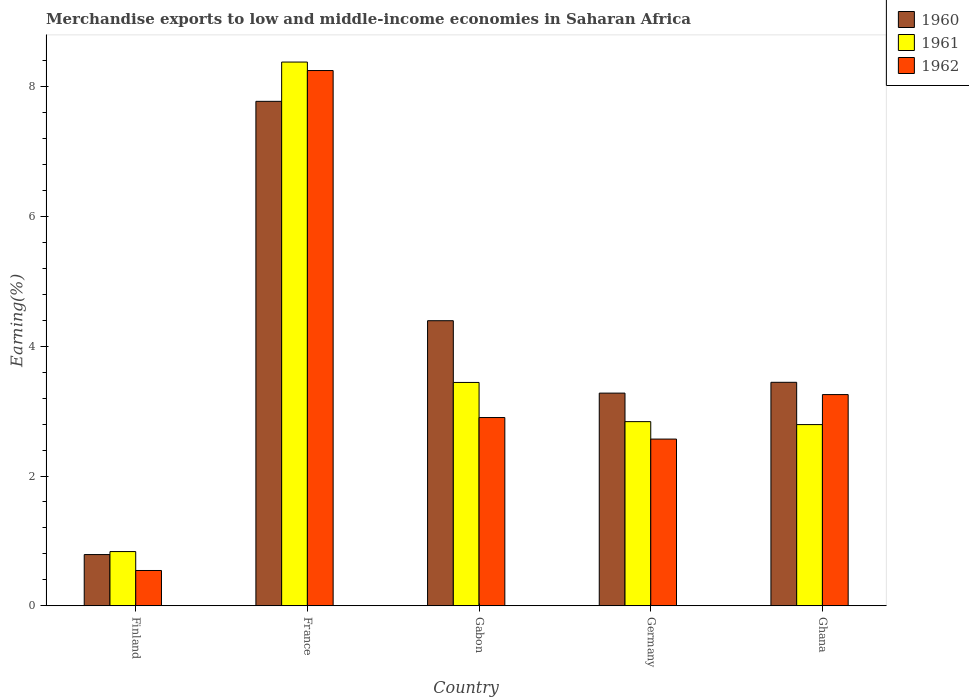How many groups of bars are there?
Your response must be concise. 5. Are the number of bars on each tick of the X-axis equal?
Make the answer very short. Yes. How many bars are there on the 4th tick from the left?
Make the answer very short. 3. What is the label of the 3rd group of bars from the left?
Make the answer very short. Gabon. In how many cases, is the number of bars for a given country not equal to the number of legend labels?
Offer a very short reply. 0. What is the percentage of amount earned from merchandise exports in 1962 in Germany?
Give a very brief answer. 2.57. Across all countries, what is the maximum percentage of amount earned from merchandise exports in 1960?
Offer a very short reply. 7.77. Across all countries, what is the minimum percentage of amount earned from merchandise exports in 1961?
Make the answer very short. 0.84. In which country was the percentage of amount earned from merchandise exports in 1961 minimum?
Give a very brief answer. Finland. What is the total percentage of amount earned from merchandise exports in 1962 in the graph?
Your answer should be compact. 17.52. What is the difference between the percentage of amount earned from merchandise exports in 1961 in France and that in Ghana?
Your answer should be very brief. 5.59. What is the difference between the percentage of amount earned from merchandise exports in 1961 in Gabon and the percentage of amount earned from merchandise exports in 1960 in Germany?
Offer a terse response. 0.16. What is the average percentage of amount earned from merchandise exports in 1962 per country?
Your answer should be very brief. 3.5. What is the difference between the percentage of amount earned from merchandise exports of/in 1960 and percentage of amount earned from merchandise exports of/in 1961 in Finland?
Offer a terse response. -0.05. In how many countries, is the percentage of amount earned from merchandise exports in 1961 greater than 4.8 %?
Your answer should be compact. 1. What is the ratio of the percentage of amount earned from merchandise exports in 1961 in Finland to that in Ghana?
Provide a short and direct response. 0.3. Is the percentage of amount earned from merchandise exports in 1961 in Gabon less than that in Germany?
Your response must be concise. No. Is the difference between the percentage of amount earned from merchandise exports in 1960 in Finland and Ghana greater than the difference between the percentage of amount earned from merchandise exports in 1961 in Finland and Ghana?
Provide a short and direct response. No. What is the difference between the highest and the second highest percentage of amount earned from merchandise exports in 1960?
Your answer should be compact. -0.95. What is the difference between the highest and the lowest percentage of amount earned from merchandise exports in 1961?
Make the answer very short. 7.54. In how many countries, is the percentage of amount earned from merchandise exports in 1962 greater than the average percentage of amount earned from merchandise exports in 1962 taken over all countries?
Make the answer very short. 1. Is the sum of the percentage of amount earned from merchandise exports in 1960 in France and Germany greater than the maximum percentage of amount earned from merchandise exports in 1961 across all countries?
Ensure brevity in your answer.  Yes. What does the 3rd bar from the left in Germany represents?
Your response must be concise. 1962. What does the 3rd bar from the right in France represents?
Offer a very short reply. 1960. How many countries are there in the graph?
Give a very brief answer. 5. What is the difference between two consecutive major ticks on the Y-axis?
Offer a terse response. 2. Are the values on the major ticks of Y-axis written in scientific E-notation?
Your answer should be compact. No. Does the graph contain grids?
Provide a short and direct response. No. How are the legend labels stacked?
Your response must be concise. Vertical. What is the title of the graph?
Offer a very short reply. Merchandise exports to low and middle-income economies in Saharan Africa. Does "1980" appear as one of the legend labels in the graph?
Your answer should be compact. No. What is the label or title of the X-axis?
Provide a short and direct response. Country. What is the label or title of the Y-axis?
Your response must be concise. Earning(%). What is the Earning(%) in 1960 in Finland?
Your answer should be very brief. 0.79. What is the Earning(%) of 1961 in Finland?
Provide a short and direct response. 0.84. What is the Earning(%) of 1962 in Finland?
Provide a short and direct response. 0.54. What is the Earning(%) in 1960 in France?
Provide a succinct answer. 7.77. What is the Earning(%) of 1961 in France?
Your answer should be very brief. 8.38. What is the Earning(%) of 1962 in France?
Keep it short and to the point. 8.25. What is the Earning(%) in 1960 in Gabon?
Provide a succinct answer. 4.39. What is the Earning(%) of 1961 in Gabon?
Offer a very short reply. 3.44. What is the Earning(%) in 1962 in Gabon?
Offer a very short reply. 2.9. What is the Earning(%) of 1960 in Germany?
Make the answer very short. 3.28. What is the Earning(%) of 1961 in Germany?
Keep it short and to the point. 2.84. What is the Earning(%) of 1962 in Germany?
Give a very brief answer. 2.57. What is the Earning(%) of 1960 in Ghana?
Make the answer very short. 3.44. What is the Earning(%) of 1961 in Ghana?
Keep it short and to the point. 2.79. What is the Earning(%) of 1962 in Ghana?
Your answer should be very brief. 3.25. Across all countries, what is the maximum Earning(%) of 1960?
Offer a terse response. 7.77. Across all countries, what is the maximum Earning(%) in 1961?
Make the answer very short. 8.38. Across all countries, what is the maximum Earning(%) of 1962?
Make the answer very short. 8.25. Across all countries, what is the minimum Earning(%) in 1960?
Your response must be concise. 0.79. Across all countries, what is the minimum Earning(%) of 1961?
Make the answer very short. 0.84. Across all countries, what is the minimum Earning(%) of 1962?
Ensure brevity in your answer.  0.54. What is the total Earning(%) of 1960 in the graph?
Provide a succinct answer. 19.68. What is the total Earning(%) in 1961 in the graph?
Provide a succinct answer. 18.29. What is the total Earning(%) in 1962 in the graph?
Offer a terse response. 17.52. What is the difference between the Earning(%) in 1960 in Finland and that in France?
Provide a short and direct response. -6.98. What is the difference between the Earning(%) in 1961 in Finland and that in France?
Ensure brevity in your answer.  -7.54. What is the difference between the Earning(%) of 1962 in Finland and that in France?
Your answer should be compact. -7.7. What is the difference between the Earning(%) in 1960 in Finland and that in Gabon?
Your response must be concise. -3.6. What is the difference between the Earning(%) in 1961 in Finland and that in Gabon?
Ensure brevity in your answer.  -2.61. What is the difference between the Earning(%) in 1962 in Finland and that in Gabon?
Make the answer very short. -2.36. What is the difference between the Earning(%) of 1960 in Finland and that in Germany?
Give a very brief answer. -2.49. What is the difference between the Earning(%) of 1961 in Finland and that in Germany?
Make the answer very short. -2. What is the difference between the Earning(%) of 1962 in Finland and that in Germany?
Your response must be concise. -2.02. What is the difference between the Earning(%) in 1960 in Finland and that in Ghana?
Your answer should be very brief. -2.65. What is the difference between the Earning(%) in 1961 in Finland and that in Ghana?
Offer a terse response. -1.96. What is the difference between the Earning(%) of 1962 in Finland and that in Ghana?
Give a very brief answer. -2.71. What is the difference between the Earning(%) in 1960 in France and that in Gabon?
Your response must be concise. 3.38. What is the difference between the Earning(%) in 1961 in France and that in Gabon?
Offer a very short reply. 4.94. What is the difference between the Earning(%) of 1962 in France and that in Gabon?
Ensure brevity in your answer.  5.35. What is the difference between the Earning(%) of 1960 in France and that in Germany?
Offer a very short reply. 4.5. What is the difference between the Earning(%) of 1961 in France and that in Germany?
Ensure brevity in your answer.  5.54. What is the difference between the Earning(%) in 1962 in France and that in Germany?
Your answer should be very brief. 5.68. What is the difference between the Earning(%) of 1960 in France and that in Ghana?
Ensure brevity in your answer.  4.33. What is the difference between the Earning(%) of 1961 in France and that in Ghana?
Your answer should be compact. 5.59. What is the difference between the Earning(%) of 1962 in France and that in Ghana?
Keep it short and to the point. 4.99. What is the difference between the Earning(%) in 1960 in Gabon and that in Germany?
Offer a very short reply. 1.12. What is the difference between the Earning(%) in 1961 in Gabon and that in Germany?
Give a very brief answer. 0.6. What is the difference between the Earning(%) of 1962 in Gabon and that in Germany?
Ensure brevity in your answer.  0.33. What is the difference between the Earning(%) in 1960 in Gabon and that in Ghana?
Offer a terse response. 0.95. What is the difference between the Earning(%) in 1961 in Gabon and that in Ghana?
Offer a terse response. 0.65. What is the difference between the Earning(%) in 1962 in Gabon and that in Ghana?
Provide a short and direct response. -0.35. What is the difference between the Earning(%) of 1960 in Germany and that in Ghana?
Provide a succinct answer. -0.17. What is the difference between the Earning(%) of 1961 in Germany and that in Ghana?
Provide a succinct answer. 0.05. What is the difference between the Earning(%) in 1962 in Germany and that in Ghana?
Offer a terse response. -0.69. What is the difference between the Earning(%) of 1960 in Finland and the Earning(%) of 1961 in France?
Your response must be concise. -7.59. What is the difference between the Earning(%) of 1960 in Finland and the Earning(%) of 1962 in France?
Offer a very short reply. -7.46. What is the difference between the Earning(%) of 1961 in Finland and the Earning(%) of 1962 in France?
Keep it short and to the point. -7.41. What is the difference between the Earning(%) of 1960 in Finland and the Earning(%) of 1961 in Gabon?
Give a very brief answer. -2.65. What is the difference between the Earning(%) in 1960 in Finland and the Earning(%) in 1962 in Gabon?
Your answer should be very brief. -2.11. What is the difference between the Earning(%) in 1961 in Finland and the Earning(%) in 1962 in Gabon?
Provide a succinct answer. -2.07. What is the difference between the Earning(%) of 1960 in Finland and the Earning(%) of 1961 in Germany?
Keep it short and to the point. -2.05. What is the difference between the Earning(%) in 1960 in Finland and the Earning(%) in 1962 in Germany?
Make the answer very short. -1.78. What is the difference between the Earning(%) of 1961 in Finland and the Earning(%) of 1962 in Germany?
Your answer should be very brief. -1.73. What is the difference between the Earning(%) of 1960 in Finland and the Earning(%) of 1961 in Ghana?
Offer a terse response. -2. What is the difference between the Earning(%) of 1960 in Finland and the Earning(%) of 1962 in Ghana?
Make the answer very short. -2.47. What is the difference between the Earning(%) of 1961 in Finland and the Earning(%) of 1962 in Ghana?
Provide a short and direct response. -2.42. What is the difference between the Earning(%) of 1960 in France and the Earning(%) of 1961 in Gabon?
Provide a short and direct response. 4.33. What is the difference between the Earning(%) of 1960 in France and the Earning(%) of 1962 in Gabon?
Your response must be concise. 4.87. What is the difference between the Earning(%) of 1961 in France and the Earning(%) of 1962 in Gabon?
Ensure brevity in your answer.  5.48. What is the difference between the Earning(%) of 1960 in France and the Earning(%) of 1961 in Germany?
Ensure brevity in your answer.  4.94. What is the difference between the Earning(%) of 1960 in France and the Earning(%) of 1962 in Germany?
Give a very brief answer. 5.21. What is the difference between the Earning(%) in 1961 in France and the Earning(%) in 1962 in Germany?
Offer a very short reply. 5.81. What is the difference between the Earning(%) in 1960 in France and the Earning(%) in 1961 in Ghana?
Keep it short and to the point. 4.98. What is the difference between the Earning(%) in 1960 in France and the Earning(%) in 1962 in Ghana?
Keep it short and to the point. 4.52. What is the difference between the Earning(%) of 1961 in France and the Earning(%) of 1962 in Ghana?
Your answer should be very brief. 5.12. What is the difference between the Earning(%) in 1960 in Gabon and the Earning(%) in 1961 in Germany?
Offer a terse response. 1.56. What is the difference between the Earning(%) in 1960 in Gabon and the Earning(%) in 1962 in Germany?
Your answer should be very brief. 1.82. What is the difference between the Earning(%) in 1961 in Gabon and the Earning(%) in 1962 in Germany?
Your answer should be compact. 0.87. What is the difference between the Earning(%) in 1960 in Gabon and the Earning(%) in 1961 in Ghana?
Provide a succinct answer. 1.6. What is the difference between the Earning(%) in 1960 in Gabon and the Earning(%) in 1962 in Ghana?
Give a very brief answer. 1.14. What is the difference between the Earning(%) in 1961 in Gabon and the Earning(%) in 1962 in Ghana?
Ensure brevity in your answer.  0.19. What is the difference between the Earning(%) in 1960 in Germany and the Earning(%) in 1961 in Ghana?
Make the answer very short. 0.48. What is the difference between the Earning(%) in 1960 in Germany and the Earning(%) in 1962 in Ghana?
Make the answer very short. 0.02. What is the difference between the Earning(%) in 1961 in Germany and the Earning(%) in 1962 in Ghana?
Ensure brevity in your answer.  -0.42. What is the average Earning(%) of 1960 per country?
Provide a succinct answer. 3.94. What is the average Earning(%) of 1961 per country?
Your response must be concise. 3.66. What is the average Earning(%) of 1962 per country?
Give a very brief answer. 3.5. What is the difference between the Earning(%) of 1960 and Earning(%) of 1961 in Finland?
Offer a terse response. -0.05. What is the difference between the Earning(%) in 1960 and Earning(%) in 1962 in Finland?
Offer a very short reply. 0.25. What is the difference between the Earning(%) in 1961 and Earning(%) in 1962 in Finland?
Provide a short and direct response. 0.29. What is the difference between the Earning(%) of 1960 and Earning(%) of 1961 in France?
Ensure brevity in your answer.  -0.61. What is the difference between the Earning(%) of 1960 and Earning(%) of 1962 in France?
Provide a short and direct response. -0.47. What is the difference between the Earning(%) of 1961 and Earning(%) of 1962 in France?
Provide a short and direct response. 0.13. What is the difference between the Earning(%) of 1960 and Earning(%) of 1961 in Gabon?
Keep it short and to the point. 0.95. What is the difference between the Earning(%) of 1960 and Earning(%) of 1962 in Gabon?
Provide a short and direct response. 1.49. What is the difference between the Earning(%) in 1961 and Earning(%) in 1962 in Gabon?
Offer a terse response. 0.54. What is the difference between the Earning(%) of 1960 and Earning(%) of 1961 in Germany?
Make the answer very short. 0.44. What is the difference between the Earning(%) in 1960 and Earning(%) in 1962 in Germany?
Provide a short and direct response. 0.71. What is the difference between the Earning(%) in 1961 and Earning(%) in 1962 in Germany?
Ensure brevity in your answer.  0.27. What is the difference between the Earning(%) in 1960 and Earning(%) in 1961 in Ghana?
Offer a very short reply. 0.65. What is the difference between the Earning(%) in 1960 and Earning(%) in 1962 in Ghana?
Provide a succinct answer. 0.19. What is the difference between the Earning(%) in 1961 and Earning(%) in 1962 in Ghana?
Give a very brief answer. -0.46. What is the ratio of the Earning(%) of 1960 in Finland to that in France?
Your answer should be very brief. 0.1. What is the ratio of the Earning(%) in 1961 in Finland to that in France?
Provide a succinct answer. 0.1. What is the ratio of the Earning(%) in 1962 in Finland to that in France?
Offer a very short reply. 0.07. What is the ratio of the Earning(%) of 1960 in Finland to that in Gabon?
Give a very brief answer. 0.18. What is the ratio of the Earning(%) in 1961 in Finland to that in Gabon?
Your answer should be very brief. 0.24. What is the ratio of the Earning(%) in 1962 in Finland to that in Gabon?
Your answer should be compact. 0.19. What is the ratio of the Earning(%) of 1960 in Finland to that in Germany?
Your answer should be very brief. 0.24. What is the ratio of the Earning(%) of 1961 in Finland to that in Germany?
Your response must be concise. 0.29. What is the ratio of the Earning(%) in 1962 in Finland to that in Germany?
Give a very brief answer. 0.21. What is the ratio of the Earning(%) in 1960 in Finland to that in Ghana?
Your answer should be very brief. 0.23. What is the ratio of the Earning(%) in 1961 in Finland to that in Ghana?
Your response must be concise. 0.3. What is the ratio of the Earning(%) of 1962 in Finland to that in Ghana?
Your answer should be very brief. 0.17. What is the ratio of the Earning(%) of 1960 in France to that in Gabon?
Your answer should be very brief. 1.77. What is the ratio of the Earning(%) of 1961 in France to that in Gabon?
Ensure brevity in your answer.  2.43. What is the ratio of the Earning(%) in 1962 in France to that in Gabon?
Keep it short and to the point. 2.84. What is the ratio of the Earning(%) in 1960 in France to that in Germany?
Offer a very short reply. 2.37. What is the ratio of the Earning(%) of 1961 in France to that in Germany?
Provide a succinct answer. 2.95. What is the ratio of the Earning(%) of 1962 in France to that in Germany?
Offer a very short reply. 3.21. What is the ratio of the Earning(%) in 1960 in France to that in Ghana?
Offer a terse response. 2.26. What is the ratio of the Earning(%) in 1961 in France to that in Ghana?
Provide a short and direct response. 3. What is the ratio of the Earning(%) in 1962 in France to that in Ghana?
Give a very brief answer. 2.53. What is the ratio of the Earning(%) of 1960 in Gabon to that in Germany?
Provide a short and direct response. 1.34. What is the ratio of the Earning(%) in 1961 in Gabon to that in Germany?
Keep it short and to the point. 1.21. What is the ratio of the Earning(%) in 1962 in Gabon to that in Germany?
Provide a succinct answer. 1.13. What is the ratio of the Earning(%) of 1960 in Gabon to that in Ghana?
Make the answer very short. 1.28. What is the ratio of the Earning(%) in 1961 in Gabon to that in Ghana?
Provide a succinct answer. 1.23. What is the ratio of the Earning(%) of 1962 in Gabon to that in Ghana?
Your answer should be very brief. 0.89. What is the ratio of the Earning(%) of 1960 in Germany to that in Ghana?
Provide a short and direct response. 0.95. What is the ratio of the Earning(%) of 1961 in Germany to that in Ghana?
Offer a terse response. 1.02. What is the ratio of the Earning(%) in 1962 in Germany to that in Ghana?
Give a very brief answer. 0.79. What is the difference between the highest and the second highest Earning(%) of 1960?
Your answer should be compact. 3.38. What is the difference between the highest and the second highest Earning(%) in 1961?
Keep it short and to the point. 4.94. What is the difference between the highest and the second highest Earning(%) in 1962?
Your answer should be very brief. 4.99. What is the difference between the highest and the lowest Earning(%) in 1960?
Keep it short and to the point. 6.98. What is the difference between the highest and the lowest Earning(%) in 1961?
Offer a terse response. 7.54. What is the difference between the highest and the lowest Earning(%) in 1962?
Keep it short and to the point. 7.7. 